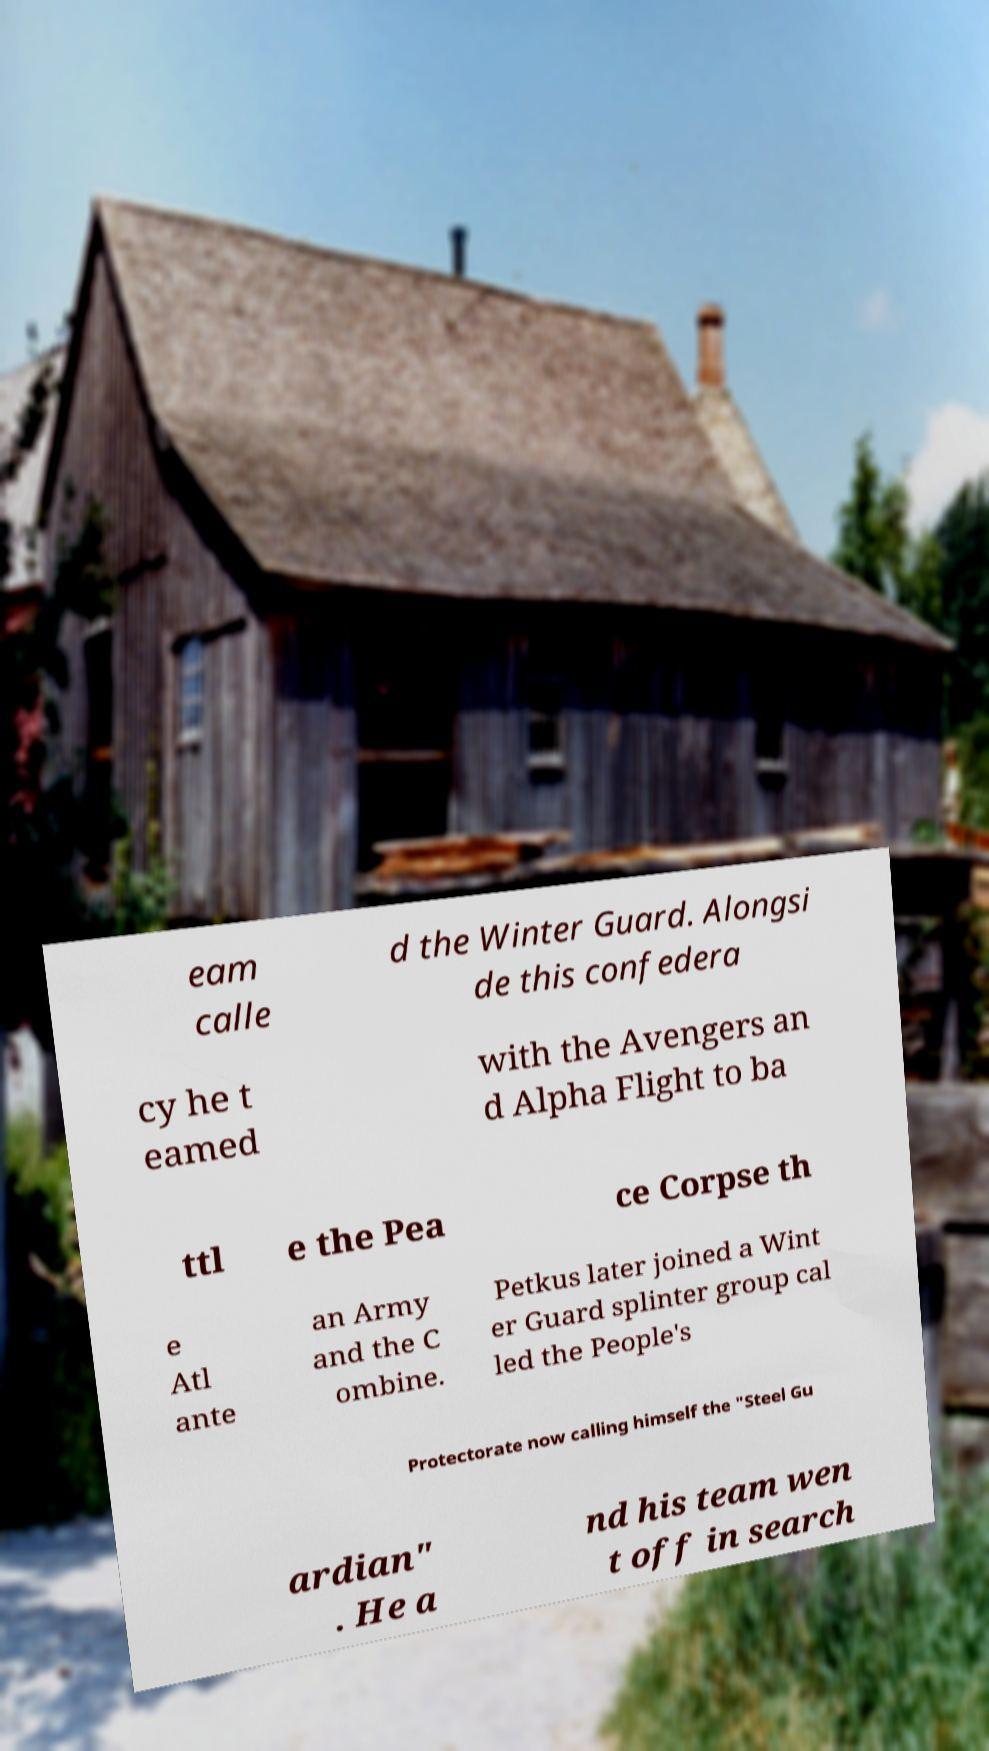I need the written content from this picture converted into text. Can you do that? eam calle d the Winter Guard. Alongsi de this confedera cy he t eamed with the Avengers an d Alpha Flight to ba ttl e the Pea ce Corpse th e Atl ante an Army and the C ombine. Petkus later joined a Wint er Guard splinter group cal led the People's Protectorate now calling himself the "Steel Gu ardian" . He a nd his team wen t off in search 